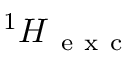<formula> <loc_0><loc_0><loc_500><loc_500>{ } ^ { 1 } H _ { e x c }</formula> 